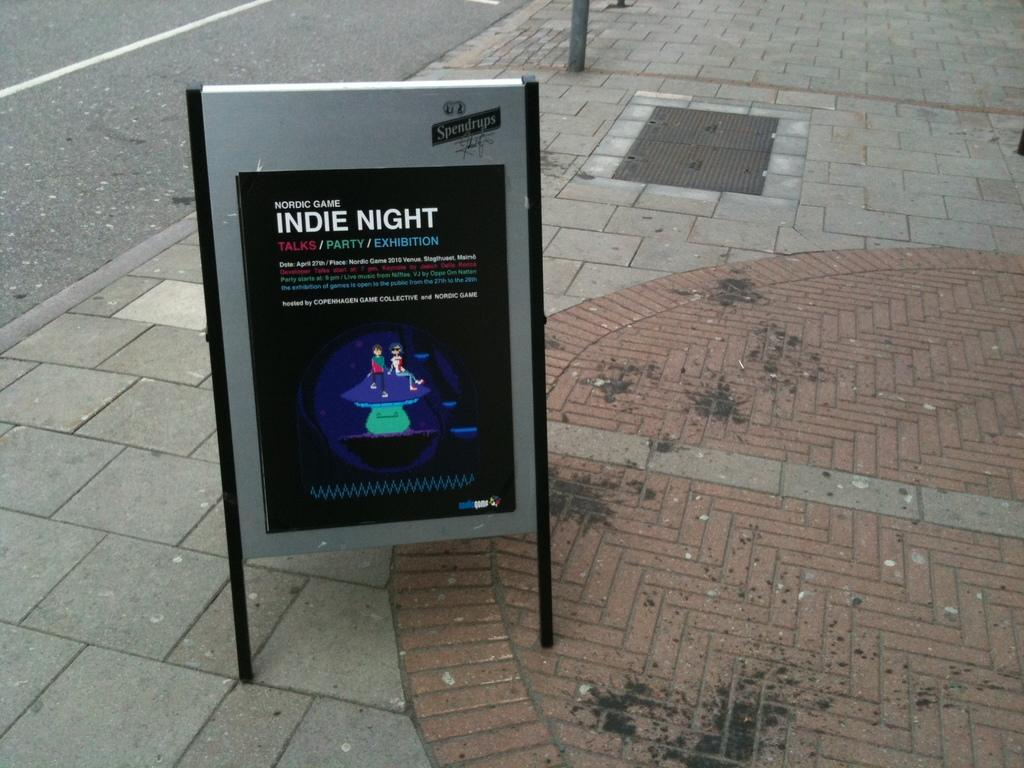<image>
Offer a succinct explanation of the picture presented. Outside stand advertisement about Indie Night with talks, Party and exhibition 